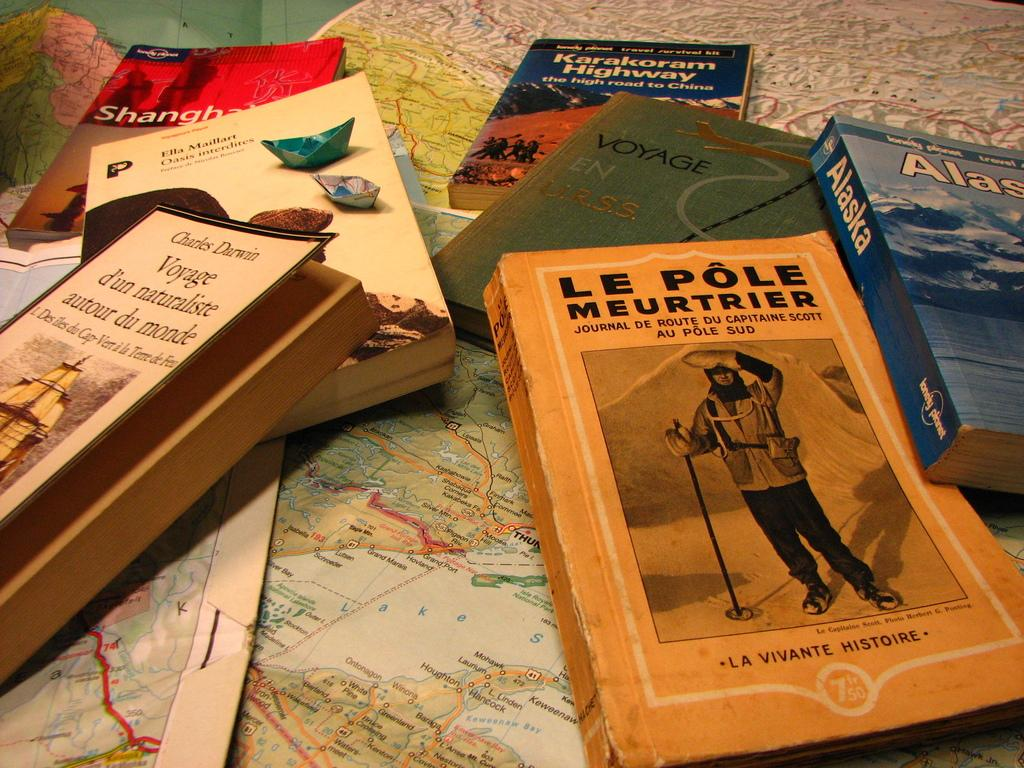<image>
Offer a succinct explanation of the picture presented. A number of book such as Karakoran Highway laid over some maps. 